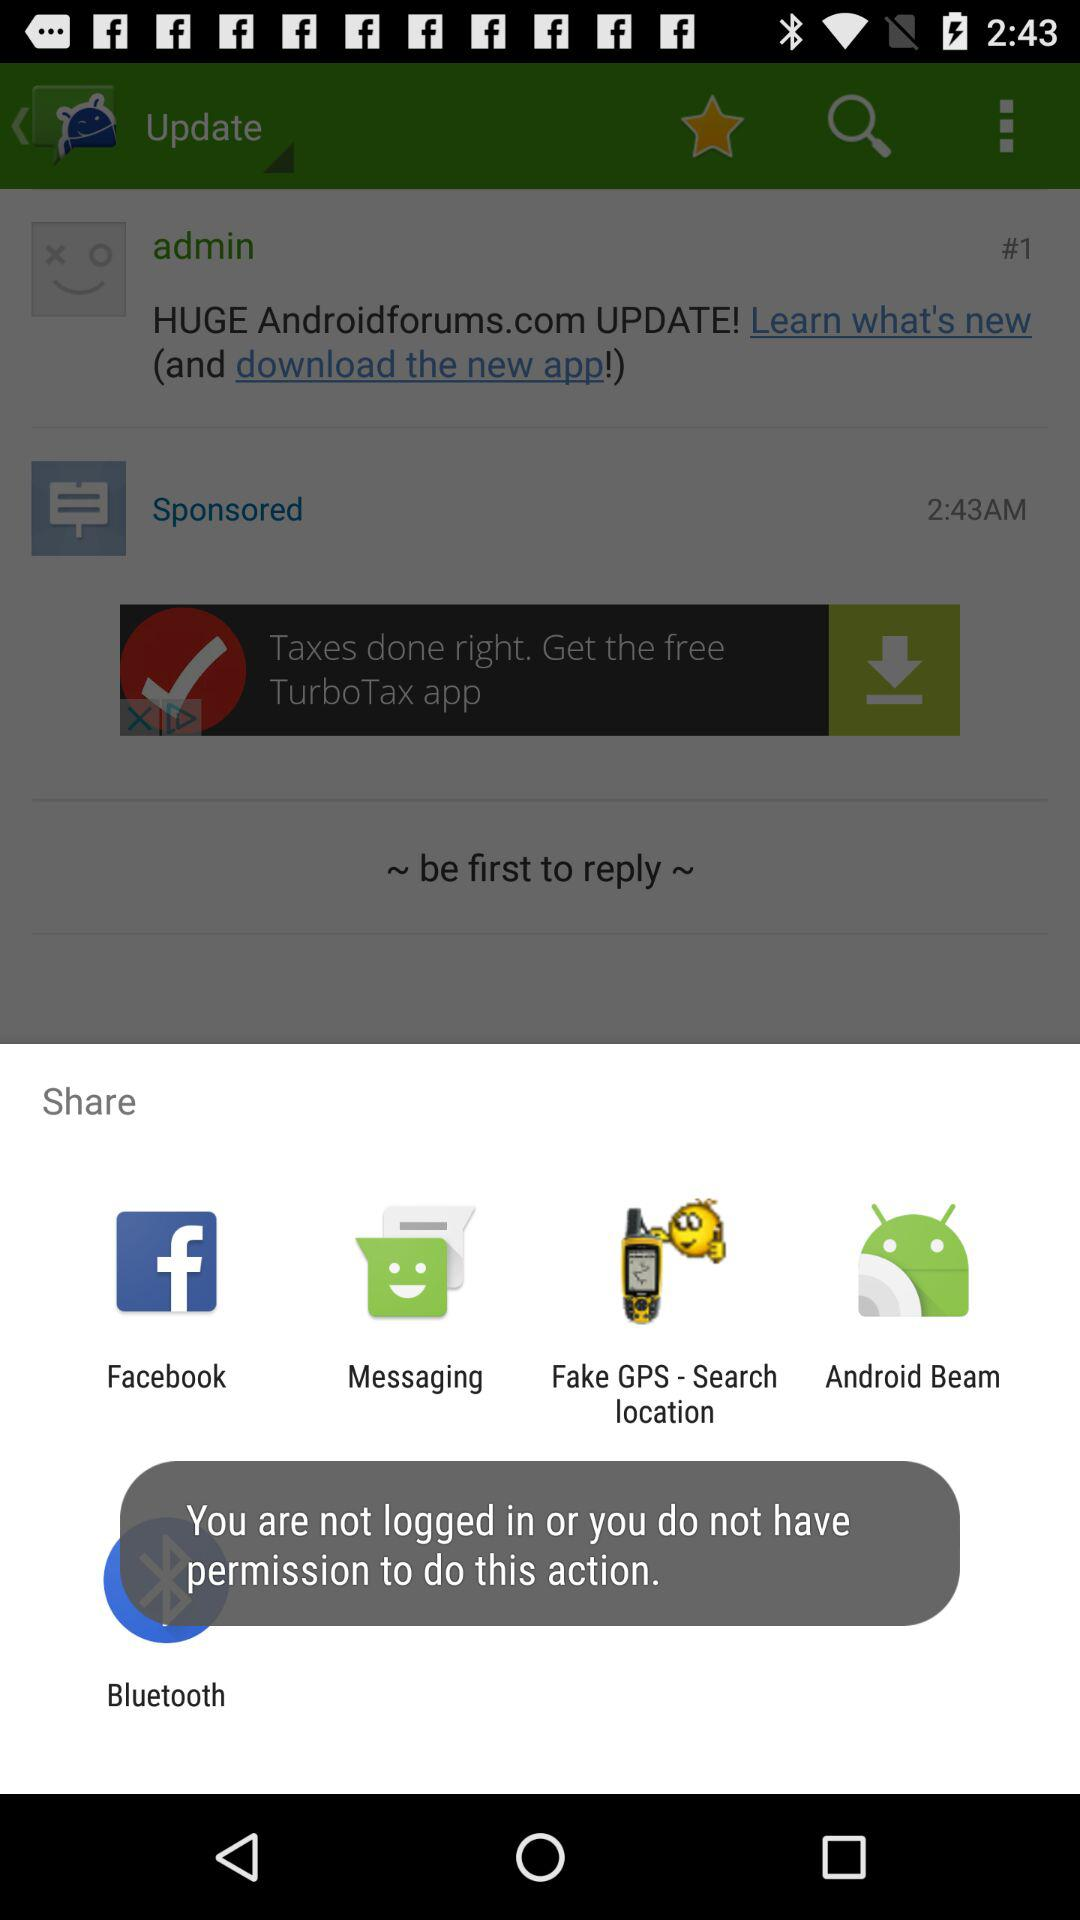Which application can be used to share? The applications that can be used to share are "Facebook", "Messaging", "Fake GPS - Search location", "Android Beam" and "Bluetooth". 